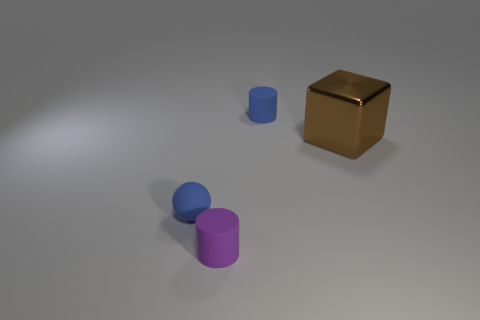Is there any other thing that has the same material as the brown thing?
Your answer should be compact. No. Does the cylinder that is behind the metallic object have the same color as the thing that is in front of the blue rubber ball?
Provide a succinct answer. No. What material is the small object behind the tiny blue object that is on the left side of the cylinder left of the small blue cylinder?
Offer a terse response. Rubber. Is there a purple matte cylinder of the same size as the brown shiny object?
Your response must be concise. No. There is a blue thing that is the same size as the blue cylinder; what is its material?
Make the answer very short. Rubber. The tiny blue thing to the left of the tiny blue cylinder has what shape?
Your answer should be compact. Sphere. Is the material of the object that is behind the large cube the same as the small cylinder that is to the left of the tiny blue cylinder?
Your answer should be very brief. Yes. How many other large objects have the same shape as the big brown thing?
Your answer should be very brief. 0. There is a tiny object that is the same color as the tiny sphere; what is it made of?
Give a very brief answer. Rubber. How many objects are either large brown shiny cubes or small matte objects that are to the right of the blue ball?
Your answer should be compact. 3. 